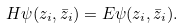<formula> <loc_0><loc_0><loc_500><loc_500>H \psi ( z _ { i } , \bar { z } _ { i } ) = E \psi ( z _ { i } , \bar { z } _ { i } ) .</formula> 